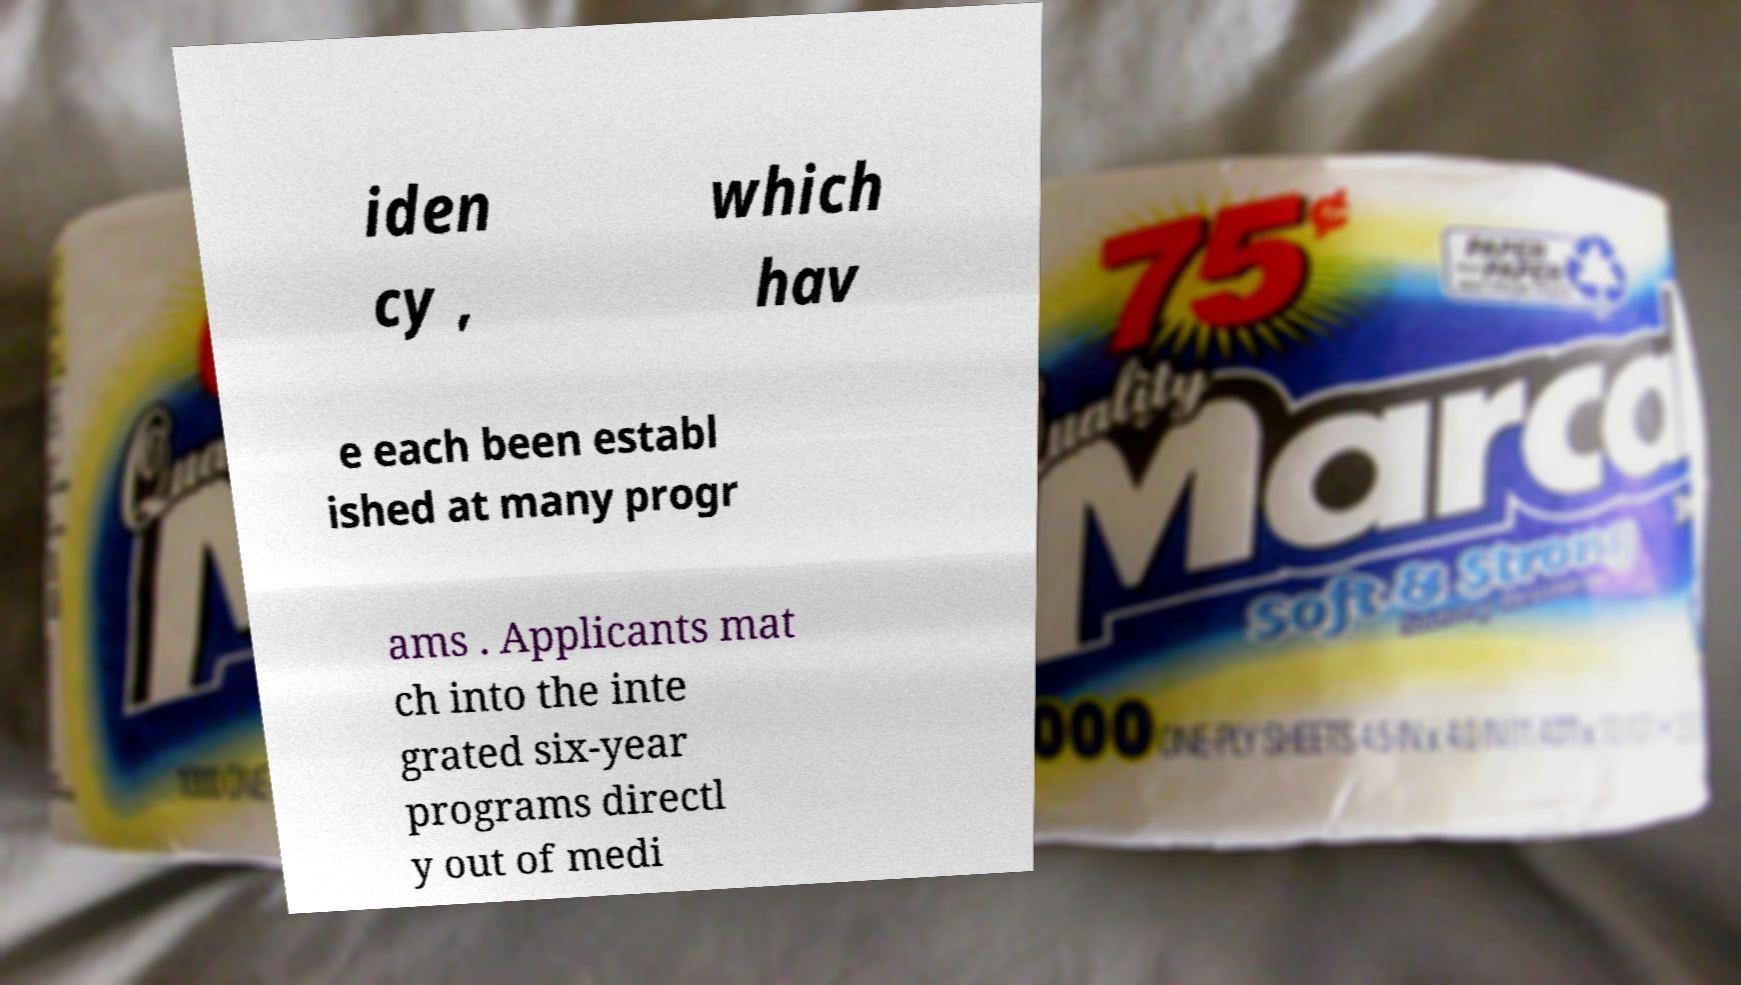I need the written content from this picture converted into text. Can you do that? iden cy , which hav e each been establ ished at many progr ams . Applicants mat ch into the inte grated six-year programs directl y out of medi 